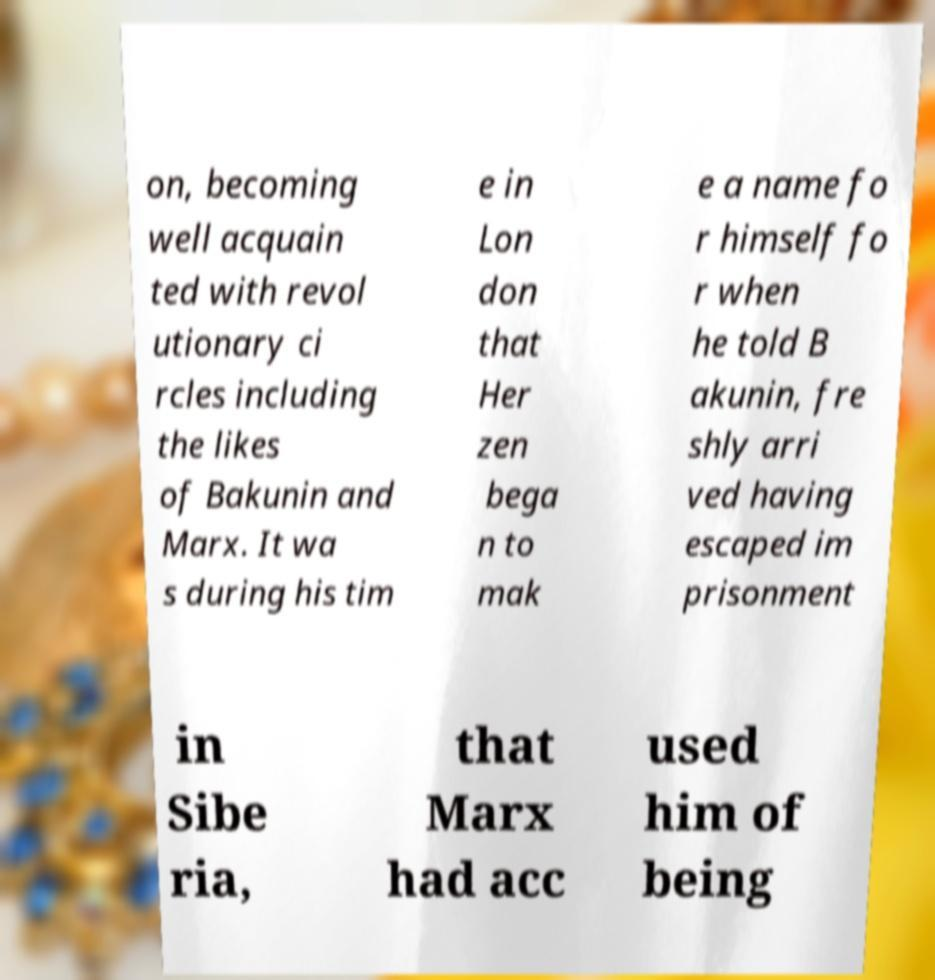I need the written content from this picture converted into text. Can you do that? on, becoming well acquain ted with revol utionary ci rcles including the likes of Bakunin and Marx. It wa s during his tim e in Lon don that Her zen bega n to mak e a name fo r himself fo r when he told B akunin, fre shly arri ved having escaped im prisonment in Sibe ria, that Marx had acc used him of being 